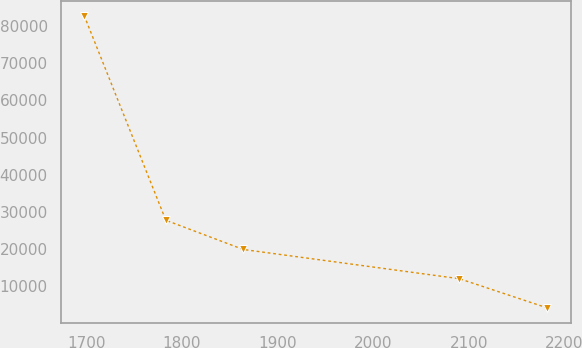Convert chart. <chart><loc_0><loc_0><loc_500><loc_500><line_chart><ecel><fcel>Unnamed: 1<nl><fcel>1697.96<fcel>82761.4<nl><fcel>1783.34<fcel>27793.3<nl><fcel>1864.25<fcel>19940.8<nl><fcel>2090.22<fcel>12088.2<nl><fcel>2182.16<fcel>4235.57<nl></chart> 